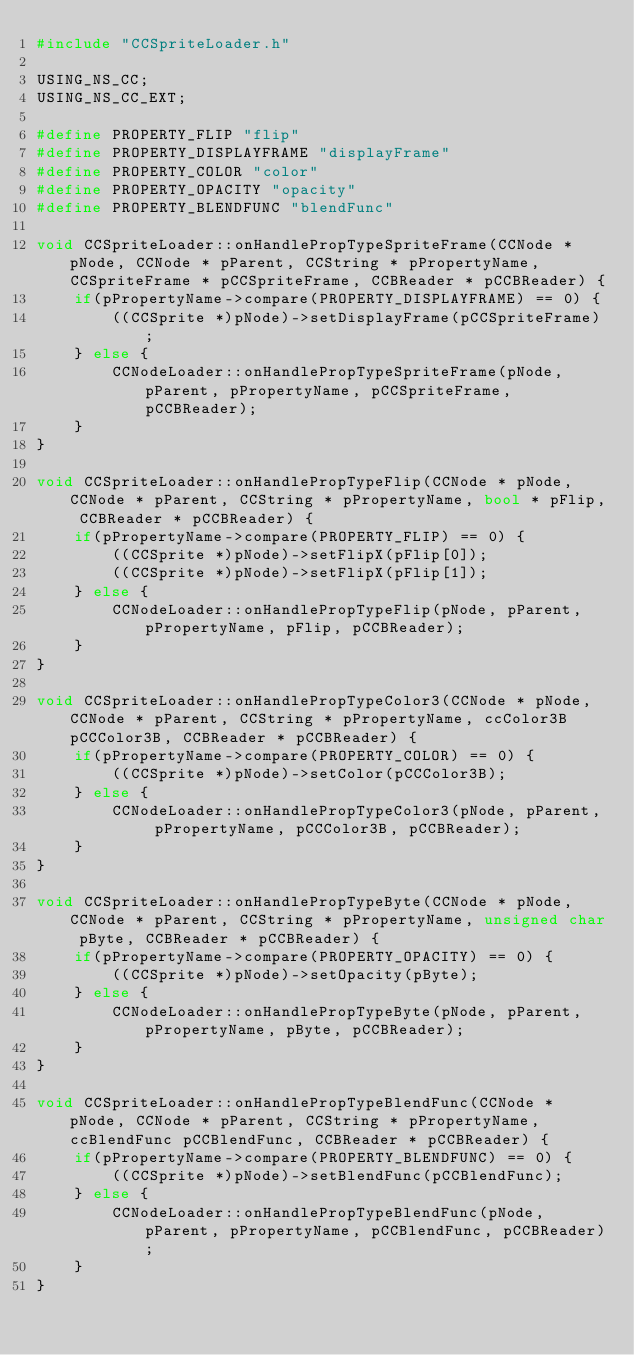Convert code to text. <code><loc_0><loc_0><loc_500><loc_500><_C++_>#include "CCSpriteLoader.h"

USING_NS_CC;
USING_NS_CC_EXT;

#define PROPERTY_FLIP "flip"
#define PROPERTY_DISPLAYFRAME "displayFrame"
#define PROPERTY_COLOR "color"
#define PROPERTY_OPACITY "opacity"
#define PROPERTY_BLENDFUNC "blendFunc"

void CCSpriteLoader::onHandlePropTypeSpriteFrame(CCNode * pNode, CCNode * pParent, CCString * pPropertyName, CCSpriteFrame * pCCSpriteFrame, CCBReader * pCCBReader) {
    if(pPropertyName->compare(PROPERTY_DISPLAYFRAME) == 0) {
        ((CCSprite *)pNode)->setDisplayFrame(pCCSpriteFrame);
    } else {
        CCNodeLoader::onHandlePropTypeSpriteFrame(pNode, pParent, pPropertyName, pCCSpriteFrame, pCCBReader);
    }
}

void CCSpriteLoader::onHandlePropTypeFlip(CCNode * pNode, CCNode * pParent, CCString * pPropertyName, bool * pFlip, CCBReader * pCCBReader) {
    if(pPropertyName->compare(PROPERTY_FLIP) == 0) {
        ((CCSprite *)pNode)->setFlipX(pFlip[0]);
        ((CCSprite *)pNode)->setFlipX(pFlip[1]);
    } else {
        CCNodeLoader::onHandlePropTypeFlip(pNode, pParent, pPropertyName, pFlip, pCCBReader);
    }
}

void CCSpriteLoader::onHandlePropTypeColor3(CCNode * pNode, CCNode * pParent, CCString * pPropertyName, ccColor3B pCCColor3B, CCBReader * pCCBReader) {
    if(pPropertyName->compare(PROPERTY_COLOR) == 0) {
        ((CCSprite *)pNode)->setColor(pCCColor3B);
    } else {
        CCNodeLoader::onHandlePropTypeColor3(pNode, pParent, pPropertyName, pCCColor3B, pCCBReader);
    }
}

void CCSpriteLoader::onHandlePropTypeByte(CCNode * pNode, CCNode * pParent, CCString * pPropertyName, unsigned char pByte, CCBReader * pCCBReader) {
    if(pPropertyName->compare(PROPERTY_OPACITY) == 0) {
        ((CCSprite *)pNode)->setOpacity(pByte);
    } else {
        CCNodeLoader::onHandlePropTypeByte(pNode, pParent, pPropertyName, pByte, pCCBReader);
    }
}

void CCSpriteLoader::onHandlePropTypeBlendFunc(CCNode * pNode, CCNode * pParent, CCString * pPropertyName, ccBlendFunc pCCBlendFunc, CCBReader * pCCBReader) {
    if(pPropertyName->compare(PROPERTY_BLENDFUNC) == 0) {
        ((CCSprite *)pNode)->setBlendFunc(pCCBlendFunc);
    } else {
        CCNodeLoader::onHandlePropTypeBlendFunc(pNode, pParent, pPropertyName, pCCBlendFunc, pCCBReader);
    }
}</code> 